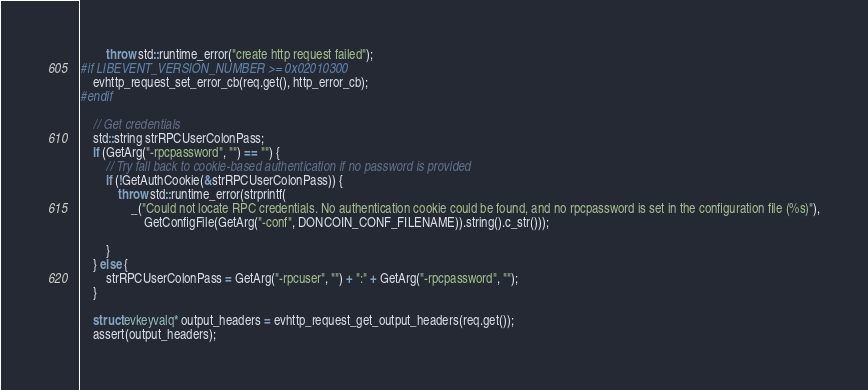Convert code to text. <code><loc_0><loc_0><loc_500><loc_500><_C++_>        throw std::runtime_error("create http request failed");
#if LIBEVENT_VERSION_NUMBER >= 0x02010300
    evhttp_request_set_error_cb(req.get(), http_error_cb);
#endif

    // Get credentials
    std::string strRPCUserColonPass;
    if (GetArg("-rpcpassword", "") == "") {
        // Try fall back to cookie-based authentication if no password is provided
        if (!GetAuthCookie(&strRPCUserColonPass)) {
            throw std::runtime_error(strprintf(
                _("Could not locate RPC credentials. No authentication cookie could be found, and no rpcpassword is set in the configuration file (%s)"),
                    GetConfigFile(GetArg("-conf", DONCOIN_CONF_FILENAME)).string().c_str()));

        }
    } else {
        strRPCUserColonPass = GetArg("-rpcuser", "") + ":" + GetArg("-rpcpassword", "");
    }

    struct evkeyvalq* output_headers = evhttp_request_get_output_headers(req.get());
    assert(output_headers);</code> 